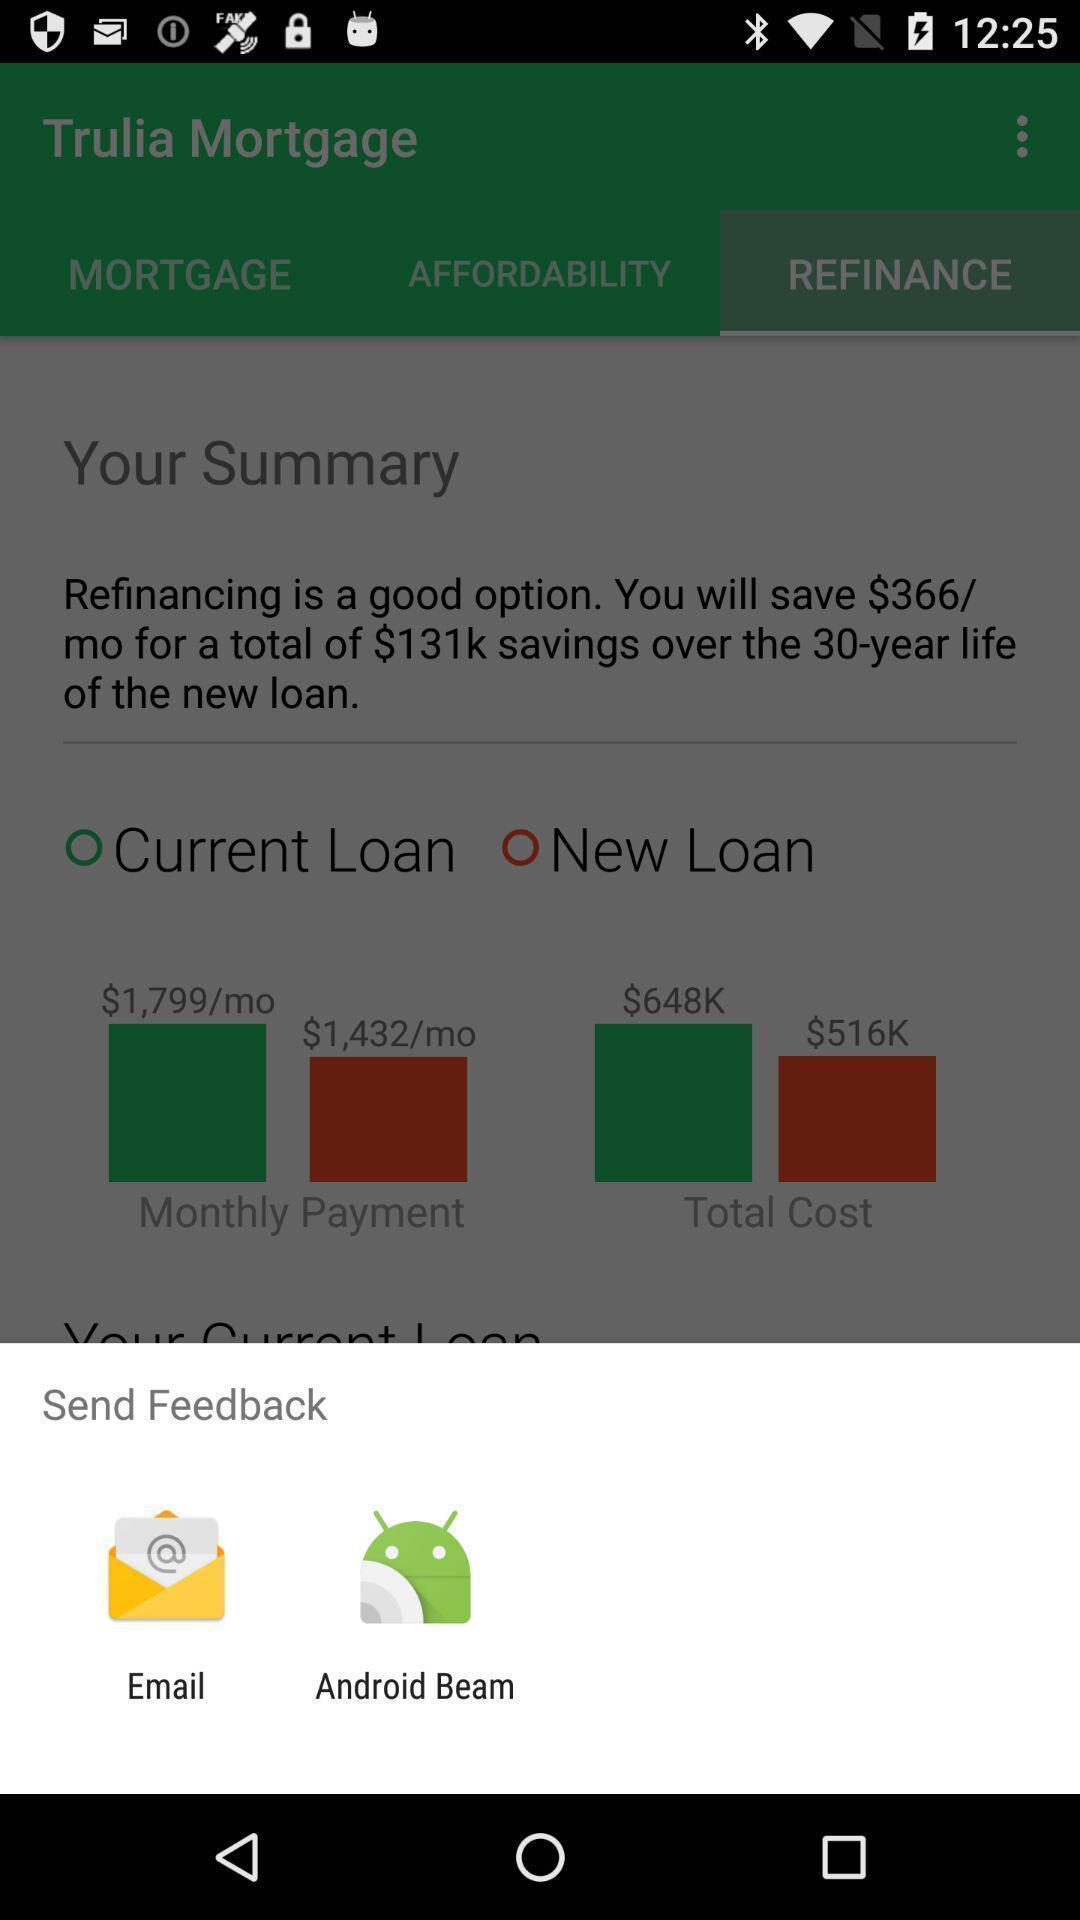Tell me about the visual elements in this screen capture. Pop-up showing the app options to send feedback. 